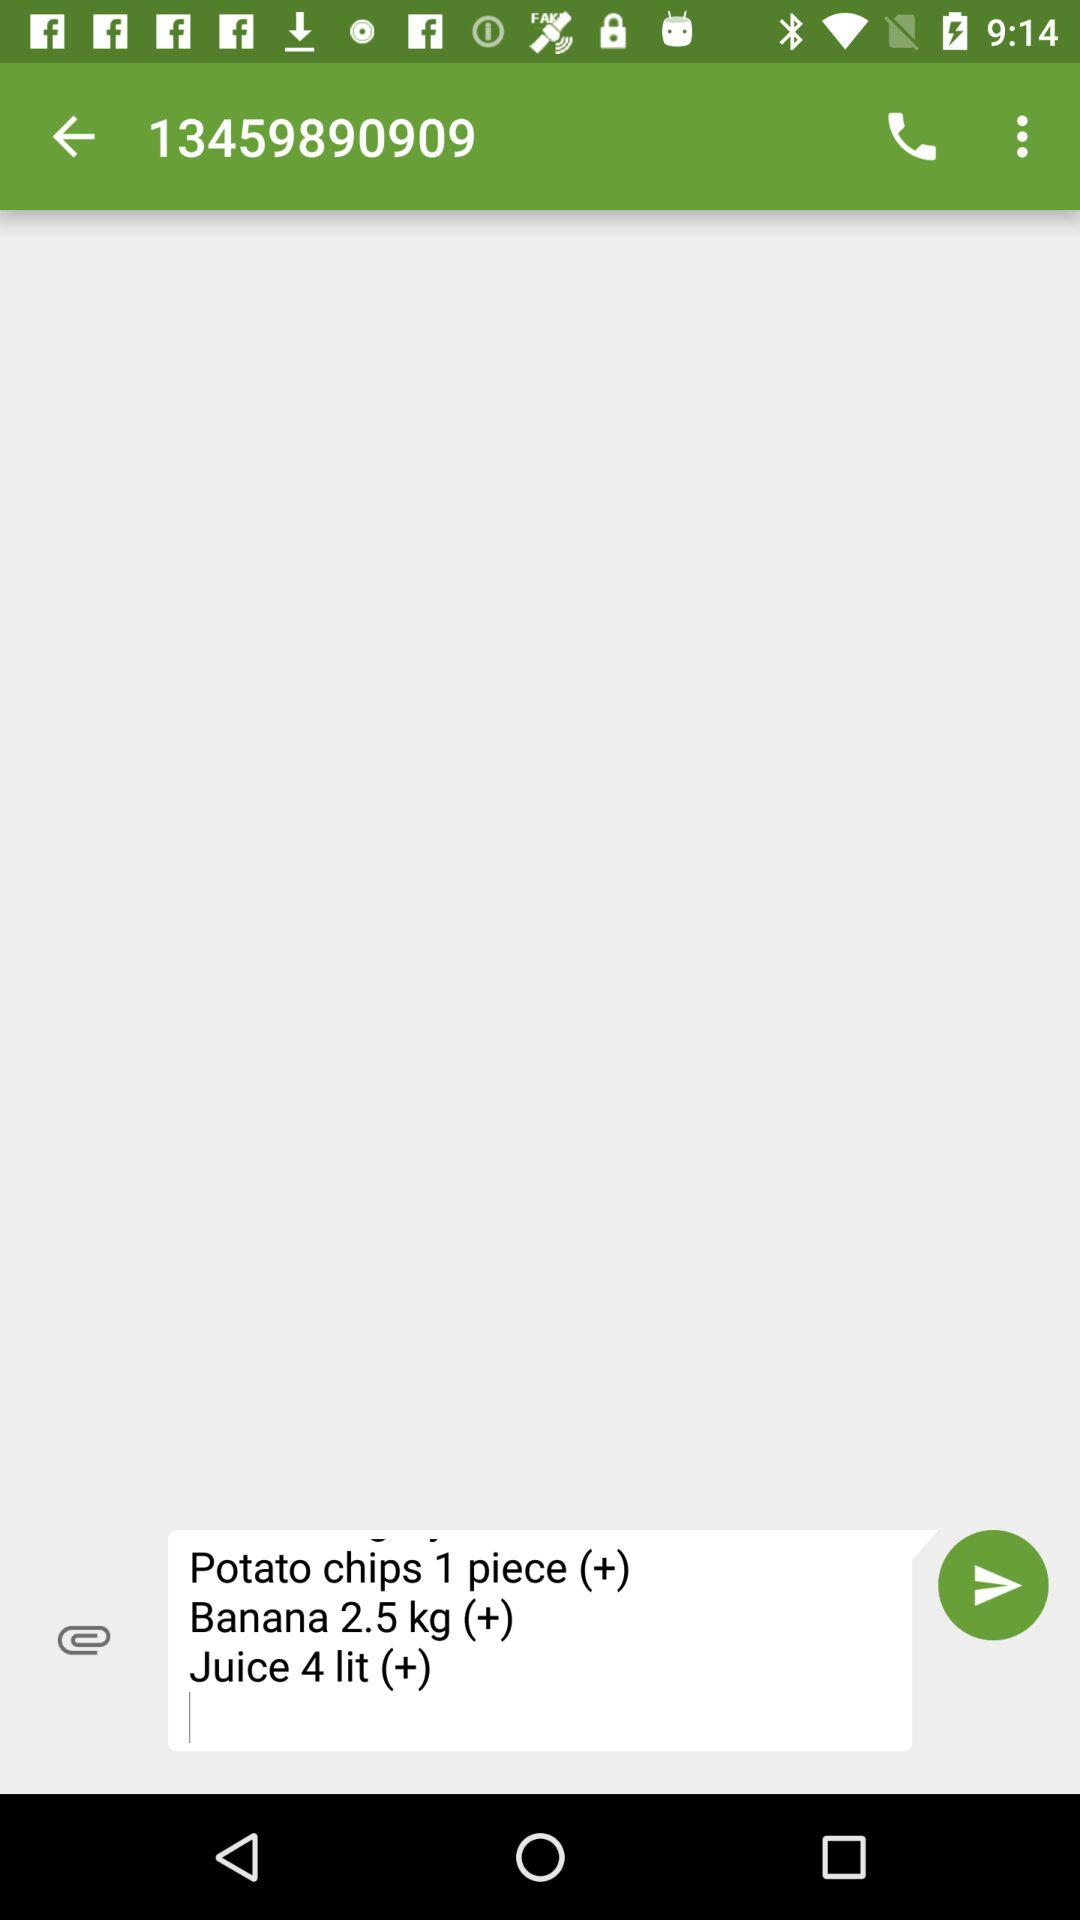What is the weight of bananas in kg? The weight of bananas is 2.5 kg. 